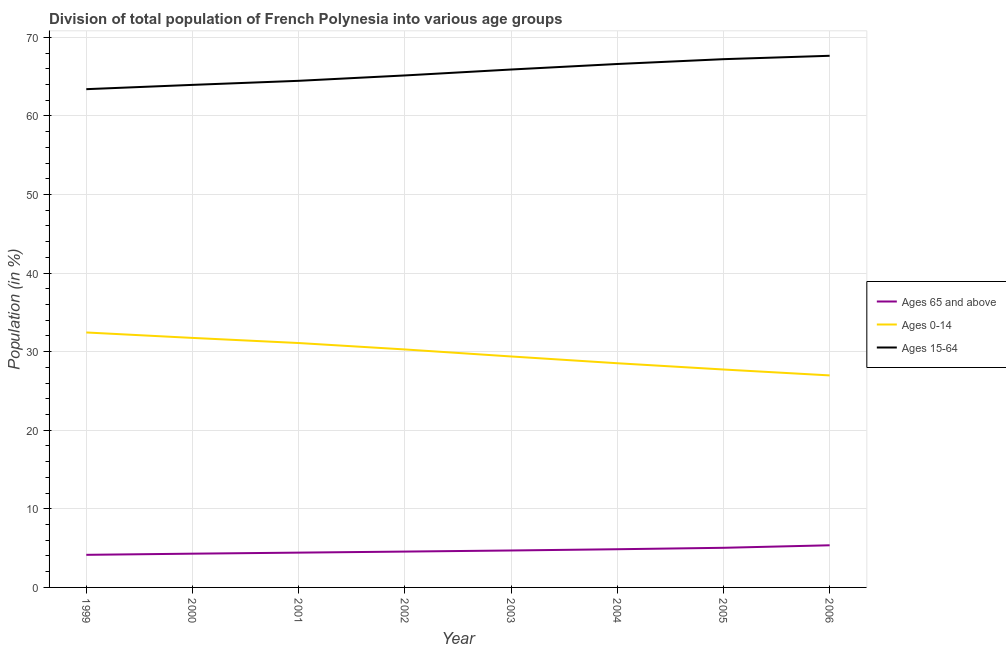Does the line corresponding to percentage of population within the age-group of 65 and above intersect with the line corresponding to percentage of population within the age-group 0-14?
Keep it short and to the point. No. Is the number of lines equal to the number of legend labels?
Give a very brief answer. Yes. What is the percentage of population within the age-group 0-14 in 2006?
Keep it short and to the point. 26.98. Across all years, what is the maximum percentage of population within the age-group 0-14?
Provide a succinct answer. 32.45. Across all years, what is the minimum percentage of population within the age-group 15-64?
Give a very brief answer. 63.41. In which year was the percentage of population within the age-group 15-64 maximum?
Keep it short and to the point. 2006. In which year was the percentage of population within the age-group 15-64 minimum?
Offer a very short reply. 1999. What is the total percentage of population within the age-group 0-14 in the graph?
Your response must be concise. 238.22. What is the difference between the percentage of population within the age-group 15-64 in 2000 and that in 2003?
Offer a very short reply. -1.95. What is the difference between the percentage of population within the age-group 15-64 in 2005 and the percentage of population within the age-group 0-14 in 2001?
Your answer should be compact. 36.12. What is the average percentage of population within the age-group 15-64 per year?
Give a very brief answer. 65.55. In the year 2003, what is the difference between the percentage of population within the age-group of 65 and above and percentage of population within the age-group 0-14?
Keep it short and to the point. -24.69. What is the ratio of the percentage of population within the age-group 15-64 in 1999 to that in 2002?
Provide a short and direct response. 0.97. What is the difference between the highest and the second highest percentage of population within the age-group 0-14?
Your answer should be compact. 0.69. What is the difference between the highest and the lowest percentage of population within the age-group 0-14?
Provide a succinct answer. 5.46. In how many years, is the percentage of population within the age-group 15-64 greater than the average percentage of population within the age-group 15-64 taken over all years?
Make the answer very short. 4. Is the sum of the percentage of population within the age-group 0-14 in 2001 and 2002 greater than the maximum percentage of population within the age-group of 65 and above across all years?
Offer a very short reply. Yes. Is it the case that in every year, the sum of the percentage of population within the age-group of 65 and above and percentage of population within the age-group 0-14 is greater than the percentage of population within the age-group 15-64?
Provide a short and direct response. No. Does the percentage of population within the age-group of 65 and above monotonically increase over the years?
Provide a short and direct response. Yes. Is the percentage of population within the age-group 15-64 strictly greater than the percentage of population within the age-group of 65 and above over the years?
Give a very brief answer. Yes. Is the percentage of population within the age-group of 65 and above strictly less than the percentage of population within the age-group 0-14 over the years?
Your response must be concise. Yes. What is the difference between two consecutive major ticks on the Y-axis?
Your answer should be compact. 10. Does the graph contain grids?
Your response must be concise. Yes. How many legend labels are there?
Your answer should be very brief. 3. What is the title of the graph?
Ensure brevity in your answer.  Division of total population of French Polynesia into various age groups
. What is the label or title of the X-axis?
Your answer should be compact. Year. What is the label or title of the Y-axis?
Provide a short and direct response. Population (in %). What is the Population (in %) in Ages 65 and above in 1999?
Give a very brief answer. 4.15. What is the Population (in %) in Ages 0-14 in 1999?
Keep it short and to the point. 32.45. What is the Population (in %) of Ages 15-64 in 1999?
Offer a very short reply. 63.41. What is the Population (in %) in Ages 65 and above in 2000?
Provide a short and direct response. 4.29. What is the Population (in %) of Ages 0-14 in 2000?
Provide a succinct answer. 31.75. What is the Population (in %) of Ages 15-64 in 2000?
Provide a short and direct response. 63.95. What is the Population (in %) in Ages 65 and above in 2001?
Provide a short and direct response. 4.43. What is the Population (in %) of Ages 0-14 in 2001?
Provide a succinct answer. 31.1. What is the Population (in %) in Ages 15-64 in 2001?
Offer a terse response. 64.47. What is the Population (in %) of Ages 65 and above in 2002?
Provide a succinct answer. 4.56. What is the Population (in %) in Ages 0-14 in 2002?
Provide a succinct answer. 30.29. What is the Population (in %) of Ages 15-64 in 2002?
Provide a succinct answer. 65.15. What is the Population (in %) of Ages 65 and above in 2003?
Your answer should be compact. 4.7. What is the Population (in %) of Ages 0-14 in 2003?
Offer a terse response. 29.39. What is the Population (in %) of Ages 15-64 in 2003?
Give a very brief answer. 65.91. What is the Population (in %) of Ages 65 and above in 2004?
Make the answer very short. 4.86. What is the Population (in %) of Ages 0-14 in 2004?
Make the answer very short. 28.53. What is the Population (in %) in Ages 15-64 in 2004?
Make the answer very short. 66.61. What is the Population (in %) of Ages 65 and above in 2005?
Offer a terse response. 5.04. What is the Population (in %) in Ages 0-14 in 2005?
Keep it short and to the point. 27.73. What is the Population (in %) of Ages 15-64 in 2005?
Keep it short and to the point. 67.22. What is the Population (in %) in Ages 65 and above in 2006?
Keep it short and to the point. 5.36. What is the Population (in %) of Ages 0-14 in 2006?
Provide a short and direct response. 26.98. What is the Population (in %) of Ages 15-64 in 2006?
Your answer should be very brief. 67.66. Across all years, what is the maximum Population (in %) in Ages 65 and above?
Your answer should be very brief. 5.36. Across all years, what is the maximum Population (in %) of Ages 0-14?
Provide a succinct answer. 32.45. Across all years, what is the maximum Population (in %) of Ages 15-64?
Your answer should be compact. 67.66. Across all years, what is the minimum Population (in %) of Ages 65 and above?
Make the answer very short. 4.15. Across all years, what is the minimum Population (in %) of Ages 0-14?
Your answer should be compact. 26.98. Across all years, what is the minimum Population (in %) in Ages 15-64?
Make the answer very short. 63.41. What is the total Population (in %) in Ages 65 and above in the graph?
Ensure brevity in your answer.  37.4. What is the total Population (in %) of Ages 0-14 in the graph?
Your answer should be compact. 238.22. What is the total Population (in %) of Ages 15-64 in the graph?
Your response must be concise. 524.38. What is the difference between the Population (in %) of Ages 65 and above in 1999 and that in 2000?
Keep it short and to the point. -0.15. What is the difference between the Population (in %) of Ages 0-14 in 1999 and that in 2000?
Offer a very short reply. 0.69. What is the difference between the Population (in %) in Ages 15-64 in 1999 and that in 2000?
Give a very brief answer. -0.55. What is the difference between the Population (in %) of Ages 65 and above in 1999 and that in 2001?
Your answer should be compact. -0.28. What is the difference between the Population (in %) in Ages 0-14 in 1999 and that in 2001?
Your response must be concise. 1.35. What is the difference between the Population (in %) of Ages 15-64 in 1999 and that in 2001?
Make the answer very short. -1.06. What is the difference between the Population (in %) in Ages 65 and above in 1999 and that in 2002?
Provide a short and direct response. -0.41. What is the difference between the Population (in %) in Ages 0-14 in 1999 and that in 2002?
Provide a succinct answer. 2.16. What is the difference between the Population (in %) of Ages 15-64 in 1999 and that in 2002?
Your answer should be very brief. -1.75. What is the difference between the Population (in %) in Ages 65 and above in 1999 and that in 2003?
Make the answer very short. -0.55. What is the difference between the Population (in %) in Ages 0-14 in 1999 and that in 2003?
Your answer should be compact. 3.05. What is the difference between the Population (in %) of Ages 15-64 in 1999 and that in 2003?
Your response must be concise. -2.5. What is the difference between the Population (in %) in Ages 65 and above in 1999 and that in 2004?
Your answer should be compact. -0.71. What is the difference between the Population (in %) of Ages 0-14 in 1999 and that in 2004?
Provide a short and direct response. 3.92. What is the difference between the Population (in %) of Ages 15-64 in 1999 and that in 2004?
Your answer should be compact. -3.2. What is the difference between the Population (in %) of Ages 65 and above in 1999 and that in 2005?
Provide a short and direct response. -0.89. What is the difference between the Population (in %) of Ages 0-14 in 1999 and that in 2005?
Provide a succinct answer. 4.71. What is the difference between the Population (in %) of Ages 15-64 in 1999 and that in 2005?
Your answer should be compact. -3.82. What is the difference between the Population (in %) in Ages 65 and above in 1999 and that in 2006?
Your answer should be very brief. -1.22. What is the difference between the Population (in %) of Ages 0-14 in 1999 and that in 2006?
Your answer should be very brief. 5.46. What is the difference between the Population (in %) of Ages 15-64 in 1999 and that in 2006?
Offer a terse response. -4.25. What is the difference between the Population (in %) of Ages 65 and above in 2000 and that in 2001?
Give a very brief answer. -0.13. What is the difference between the Population (in %) of Ages 0-14 in 2000 and that in 2001?
Your answer should be compact. 0.65. What is the difference between the Population (in %) of Ages 15-64 in 2000 and that in 2001?
Offer a very short reply. -0.52. What is the difference between the Population (in %) of Ages 65 and above in 2000 and that in 2002?
Your response must be concise. -0.27. What is the difference between the Population (in %) of Ages 0-14 in 2000 and that in 2002?
Provide a short and direct response. 1.47. What is the difference between the Population (in %) of Ages 15-64 in 2000 and that in 2002?
Ensure brevity in your answer.  -1.2. What is the difference between the Population (in %) in Ages 65 and above in 2000 and that in 2003?
Make the answer very short. -0.41. What is the difference between the Population (in %) in Ages 0-14 in 2000 and that in 2003?
Provide a short and direct response. 2.36. What is the difference between the Population (in %) of Ages 15-64 in 2000 and that in 2003?
Keep it short and to the point. -1.95. What is the difference between the Population (in %) of Ages 65 and above in 2000 and that in 2004?
Ensure brevity in your answer.  -0.57. What is the difference between the Population (in %) in Ages 0-14 in 2000 and that in 2004?
Keep it short and to the point. 3.22. What is the difference between the Population (in %) of Ages 15-64 in 2000 and that in 2004?
Make the answer very short. -2.66. What is the difference between the Population (in %) of Ages 65 and above in 2000 and that in 2005?
Your answer should be very brief. -0.75. What is the difference between the Population (in %) in Ages 0-14 in 2000 and that in 2005?
Your answer should be very brief. 4.02. What is the difference between the Population (in %) in Ages 15-64 in 2000 and that in 2005?
Make the answer very short. -3.27. What is the difference between the Population (in %) in Ages 65 and above in 2000 and that in 2006?
Keep it short and to the point. -1.07. What is the difference between the Population (in %) of Ages 0-14 in 2000 and that in 2006?
Ensure brevity in your answer.  4.77. What is the difference between the Population (in %) of Ages 15-64 in 2000 and that in 2006?
Keep it short and to the point. -3.7. What is the difference between the Population (in %) of Ages 65 and above in 2001 and that in 2002?
Your answer should be compact. -0.13. What is the difference between the Population (in %) in Ages 0-14 in 2001 and that in 2002?
Offer a very short reply. 0.82. What is the difference between the Population (in %) in Ages 15-64 in 2001 and that in 2002?
Give a very brief answer. -0.68. What is the difference between the Population (in %) in Ages 65 and above in 2001 and that in 2003?
Keep it short and to the point. -0.27. What is the difference between the Population (in %) of Ages 0-14 in 2001 and that in 2003?
Ensure brevity in your answer.  1.71. What is the difference between the Population (in %) in Ages 15-64 in 2001 and that in 2003?
Provide a succinct answer. -1.44. What is the difference between the Population (in %) of Ages 65 and above in 2001 and that in 2004?
Make the answer very short. -0.43. What is the difference between the Population (in %) of Ages 0-14 in 2001 and that in 2004?
Provide a short and direct response. 2.57. What is the difference between the Population (in %) in Ages 15-64 in 2001 and that in 2004?
Ensure brevity in your answer.  -2.14. What is the difference between the Population (in %) of Ages 65 and above in 2001 and that in 2005?
Your response must be concise. -0.61. What is the difference between the Population (in %) of Ages 0-14 in 2001 and that in 2005?
Ensure brevity in your answer.  3.37. What is the difference between the Population (in %) in Ages 15-64 in 2001 and that in 2005?
Provide a short and direct response. -2.75. What is the difference between the Population (in %) in Ages 65 and above in 2001 and that in 2006?
Offer a very short reply. -0.93. What is the difference between the Population (in %) in Ages 0-14 in 2001 and that in 2006?
Your answer should be very brief. 4.12. What is the difference between the Population (in %) in Ages 15-64 in 2001 and that in 2006?
Give a very brief answer. -3.19. What is the difference between the Population (in %) of Ages 65 and above in 2002 and that in 2003?
Make the answer very short. -0.14. What is the difference between the Population (in %) in Ages 0-14 in 2002 and that in 2003?
Keep it short and to the point. 0.89. What is the difference between the Population (in %) in Ages 15-64 in 2002 and that in 2003?
Make the answer very short. -0.75. What is the difference between the Population (in %) in Ages 65 and above in 2002 and that in 2004?
Make the answer very short. -0.3. What is the difference between the Population (in %) in Ages 0-14 in 2002 and that in 2004?
Make the answer very short. 1.75. What is the difference between the Population (in %) of Ages 15-64 in 2002 and that in 2004?
Offer a very short reply. -1.46. What is the difference between the Population (in %) of Ages 65 and above in 2002 and that in 2005?
Make the answer very short. -0.48. What is the difference between the Population (in %) in Ages 0-14 in 2002 and that in 2005?
Your response must be concise. 2.55. What is the difference between the Population (in %) of Ages 15-64 in 2002 and that in 2005?
Keep it short and to the point. -2.07. What is the difference between the Population (in %) of Ages 65 and above in 2002 and that in 2006?
Ensure brevity in your answer.  -0.8. What is the difference between the Population (in %) of Ages 0-14 in 2002 and that in 2006?
Make the answer very short. 3.3. What is the difference between the Population (in %) of Ages 15-64 in 2002 and that in 2006?
Your answer should be compact. -2.5. What is the difference between the Population (in %) of Ages 65 and above in 2003 and that in 2004?
Keep it short and to the point. -0.16. What is the difference between the Population (in %) in Ages 0-14 in 2003 and that in 2004?
Keep it short and to the point. 0.86. What is the difference between the Population (in %) in Ages 15-64 in 2003 and that in 2004?
Ensure brevity in your answer.  -0.7. What is the difference between the Population (in %) in Ages 65 and above in 2003 and that in 2005?
Ensure brevity in your answer.  -0.34. What is the difference between the Population (in %) of Ages 0-14 in 2003 and that in 2005?
Offer a terse response. 1.66. What is the difference between the Population (in %) in Ages 15-64 in 2003 and that in 2005?
Your answer should be compact. -1.32. What is the difference between the Population (in %) in Ages 65 and above in 2003 and that in 2006?
Offer a very short reply. -0.66. What is the difference between the Population (in %) in Ages 0-14 in 2003 and that in 2006?
Your response must be concise. 2.41. What is the difference between the Population (in %) in Ages 15-64 in 2003 and that in 2006?
Provide a succinct answer. -1.75. What is the difference between the Population (in %) of Ages 65 and above in 2004 and that in 2005?
Make the answer very short. -0.18. What is the difference between the Population (in %) in Ages 0-14 in 2004 and that in 2005?
Provide a short and direct response. 0.8. What is the difference between the Population (in %) in Ages 15-64 in 2004 and that in 2005?
Provide a succinct answer. -0.62. What is the difference between the Population (in %) of Ages 65 and above in 2004 and that in 2006?
Offer a terse response. -0.5. What is the difference between the Population (in %) in Ages 0-14 in 2004 and that in 2006?
Keep it short and to the point. 1.55. What is the difference between the Population (in %) in Ages 15-64 in 2004 and that in 2006?
Provide a succinct answer. -1.05. What is the difference between the Population (in %) in Ages 65 and above in 2005 and that in 2006?
Give a very brief answer. -0.32. What is the difference between the Population (in %) of Ages 0-14 in 2005 and that in 2006?
Your answer should be compact. 0.75. What is the difference between the Population (in %) in Ages 15-64 in 2005 and that in 2006?
Ensure brevity in your answer.  -0.43. What is the difference between the Population (in %) of Ages 65 and above in 1999 and the Population (in %) of Ages 0-14 in 2000?
Give a very brief answer. -27.6. What is the difference between the Population (in %) of Ages 65 and above in 1999 and the Population (in %) of Ages 15-64 in 2000?
Offer a terse response. -59.8. What is the difference between the Population (in %) in Ages 0-14 in 1999 and the Population (in %) in Ages 15-64 in 2000?
Keep it short and to the point. -31.51. What is the difference between the Population (in %) in Ages 65 and above in 1999 and the Population (in %) in Ages 0-14 in 2001?
Provide a short and direct response. -26.95. What is the difference between the Population (in %) of Ages 65 and above in 1999 and the Population (in %) of Ages 15-64 in 2001?
Keep it short and to the point. -60.32. What is the difference between the Population (in %) in Ages 0-14 in 1999 and the Population (in %) in Ages 15-64 in 2001?
Make the answer very short. -32.03. What is the difference between the Population (in %) of Ages 65 and above in 1999 and the Population (in %) of Ages 0-14 in 2002?
Offer a terse response. -26.14. What is the difference between the Population (in %) of Ages 65 and above in 1999 and the Population (in %) of Ages 15-64 in 2002?
Provide a succinct answer. -61.01. What is the difference between the Population (in %) in Ages 0-14 in 1999 and the Population (in %) in Ages 15-64 in 2002?
Offer a very short reply. -32.71. What is the difference between the Population (in %) in Ages 65 and above in 1999 and the Population (in %) in Ages 0-14 in 2003?
Offer a very short reply. -25.24. What is the difference between the Population (in %) in Ages 65 and above in 1999 and the Population (in %) in Ages 15-64 in 2003?
Your answer should be very brief. -61.76. What is the difference between the Population (in %) in Ages 0-14 in 1999 and the Population (in %) in Ages 15-64 in 2003?
Provide a short and direct response. -33.46. What is the difference between the Population (in %) in Ages 65 and above in 1999 and the Population (in %) in Ages 0-14 in 2004?
Ensure brevity in your answer.  -24.38. What is the difference between the Population (in %) of Ages 65 and above in 1999 and the Population (in %) of Ages 15-64 in 2004?
Offer a very short reply. -62.46. What is the difference between the Population (in %) in Ages 0-14 in 1999 and the Population (in %) in Ages 15-64 in 2004?
Your answer should be very brief. -34.16. What is the difference between the Population (in %) of Ages 65 and above in 1999 and the Population (in %) of Ages 0-14 in 2005?
Ensure brevity in your answer.  -23.59. What is the difference between the Population (in %) in Ages 65 and above in 1999 and the Population (in %) in Ages 15-64 in 2005?
Provide a succinct answer. -63.08. What is the difference between the Population (in %) in Ages 0-14 in 1999 and the Population (in %) in Ages 15-64 in 2005?
Provide a succinct answer. -34.78. What is the difference between the Population (in %) of Ages 65 and above in 1999 and the Population (in %) of Ages 0-14 in 2006?
Offer a very short reply. -22.83. What is the difference between the Population (in %) in Ages 65 and above in 1999 and the Population (in %) in Ages 15-64 in 2006?
Ensure brevity in your answer.  -63.51. What is the difference between the Population (in %) in Ages 0-14 in 1999 and the Population (in %) in Ages 15-64 in 2006?
Offer a terse response. -35.21. What is the difference between the Population (in %) of Ages 65 and above in 2000 and the Population (in %) of Ages 0-14 in 2001?
Ensure brevity in your answer.  -26.81. What is the difference between the Population (in %) in Ages 65 and above in 2000 and the Population (in %) in Ages 15-64 in 2001?
Your answer should be very brief. -60.18. What is the difference between the Population (in %) of Ages 0-14 in 2000 and the Population (in %) of Ages 15-64 in 2001?
Your response must be concise. -32.72. What is the difference between the Population (in %) of Ages 65 and above in 2000 and the Population (in %) of Ages 0-14 in 2002?
Make the answer very short. -25.99. What is the difference between the Population (in %) of Ages 65 and above in 2000 and the Population (in %) of Ages 15-64 in 2002?
Provide a short and direct response. -60.86. What is the difference between the Population (in %) of Ages 0-14 in 2000 and the Population (in %) of Ages 15-64 in 2002?
Make the answer very short. -33.4. What is the difference between the Population (in %) in Ages 65 and above in 2000 and the Population (in %) in Ages 0-14 in 2003?
Provide a succinct answer. -25.1. What is the difference between the Population (in %) in Ages 65 and above in 2000 and the Population (in %) in Ages 15-64 in 2003?
Provide a short and direct response. -61.61. What is the difference between the Population (in %) in Ages 0-14 in 2000 and the Population (in %) in Ages 15-64 in 2003?
Your answer should be very brief. -34.15. What is the difference between the Population (in %) of Ages 65 and above in 2000 and the Population (in %) of Ages 0-14 in 2004?
Your response must be concise. -24.24. What is the difference between the Population (in %) in Ages 65 and above in 2000 and the Population (in %) in Ages 15-64 in 2004?
Your response must be concise. -62.31. What is the difference between the Population (in %) of Ages 0-14 in 2000 and the Population (in %) of Ages 15-64 in 2004?
Your answer should be very brief. -34.86. What is the difference between the Population (in %) in Ages 65 and above in 2000 and the Population (in %) in Ages 0-14 in 2005?
Offer a very short reply. -23.44. What is the difference between the Population (in %) in Ages 65 and above in 2000 and the Population (in %) in Ages 15-64 in 2005?
Ensure brevity in your answer.  -62.93. What is the difference between the Population (in %) of Ages 0-14 in 2000 and the Population (in %) of Ages 15-64 in 2005?
Offer a terse response. -35.47. What is the difference between the Population (in %) in Ages 65 and above in 2000 and the Population (in %) in Ages 0-14 in 2006?
Your answer should be compact. -22.69. What is the difference between the Population (in %) in Ages 65 and above in 2000 and the Population (in %) in Ages 15-64 in 2006?
Offer a very short reply. -63.36. What is the difference between the Population (in %) of Ages 0-14 in 2000 and the Population (in %) of Ages 15-64 in 2006?
Give a very brief answer. -35.9. What is the difference between the Population (in %) in Ages 65 and above in 2001 and the Population (in %) in Ages 0-14 in 2002?
Provide a succinct answer. -25.86. What is the difference between the Population (in %) in Ages 65 and above in 2001 and the Population (in %) in Ages 15-64 in 2002?
Provide a succinct answer. -60.73. What is the difference between the Population (in %) of Ages 0-14 in 2001 and the Population (in %) of Ages 15-64 in 2002?
Keep it short and to the point. -34.05. What is the difference between the Population (in %) in Ages 65 and above in 2001 and the Population (in %) in Ages 0-14 in 2003?
Your answer should be compact. -24.96. What is the difference between the Population (in %) of Ages 65 and above in 2001 and the Population (in %) of Ages 15-64 in 2003?
Give a very brief answer. -61.48. What is the difference between the Population (in %) of Ages 0-14 in 2001 and the Population (in %) of Ages 15-64 in 2003?
Offer a terse response. -34.81. What is the difference between the Population (in %) of Ages 65 and above in 2001 and the Population (in %) of Ages 0-14 in 2004?
Ensure brevity in your answer.  -24.1. What is the difference between the Population (in %) in Ages 65 and above in 2001 and the Population (in %) in Ages 15-64 in 2004?
Ensure brevity in your answer.  -62.18. What is the difference between the Population (in %) in Ages 0-14 in 2001 and the Population (in %) in Ages 15-64 in 2004?
Your answer should be compact. -35.51. What is the difference between the Population (in %) of Ages 65 and above in 2001 and the Population (in %) of Ages 0-14 in 2005?
Provide a short and direct response. -23.3. What is the difference between the Population (in %) of Ages 65 and above in 2001 and the Population (in %) of Ages 15-64 in 2005?
Your response must be concise. -62.8. What is the difference between the Population (in %) in Ages 0-14 in 2001 and the Population (in %) in Ages 15-64 in 2005?
Your answer should be very brief. -36.12. What is the difference between the Population (in %) of Ages 65 and above in 2001 and the Population (in %) of Ages 0-14 in 2006?
Make the answer very short. -22.55. What is the difference between the Population (in %) of Ages 65 and above in 2001 and the Population (in %) of Ages 15-64 in 2006?
Provide a succinct answer. -63.23. What is the difference between the Population (in %) in Ages 0-14 in 2001 and the Population (in %) in Ages 15-64 in 2006?
Provide a short and direct response. -36.56. What is the difference between the Population (in %) of Ages 65 and above in 2002 and the Population (in %) of Ages 0-14 in 2003?
Your response must be concise. -24.83. What is the difference between the Population (in %) of Ages 65 and above in 2002 and the Population (in %) of Ages 15-64 in 2003?
Your response must be concise. -61.35. What is the difference between the Population (in %) of Ages 0-14 in 2002 and the Population (in %) of Ages 15-64 in 2003?
Make the answer very short. -35.62. What is the difference between the Population (in %) of Ages 65 and above in 2002 and the Population (in %) of Ages 0-14 in 2004?
Provide a succinct answer. -23.97. What is the difference between the Population (in %) in Ages 65 and above in 2002 and the Population (in %) in Ages 15-64 in 2004?
Your answer should be very brief. -62.05. What is the difference between the Population (in %) in Ages 0-14 in 2002 and the Population (in %) in Ages 15-64 in 2004?
Give a very brief answer. -36.32. What is the difference between the Population (in %) in Ages 65 and above in 2002 and the Population (in %) in Ages 0-14 in 2005?
Ensure brevity in your answer.  -23.17. What is the difference between the Population (in %) of Ages 65 and above in 2002 and the Population (in %) of Ages 15-64 in 2005?
Keep it short and to the point. -62.66. What is the difference between the Population (in %) in Ages 0-14 in 2002 and the Population (in %) in Ages 15-64 in 2005?
Give a very brief answer. -36.94. What is the difference between the Population (in %) of Ages 65 and above in 2002 and the Population (in %) of Ages 0-14 in 2006?
Offer a terse response. -22.42. What is the difference between the Population (in %) of Ages 65 and above in 2002 and the Population (in %) of Ages 15-64 in 2006?
Your response must be concise. -63.09. What is the difference between the Population (in %) in Ages 0-14 in 2002 and the Population (in %) in Ages 15-64 in 2006?
Give a very brief answer. -37.37. What is the difference between the Population (in %) of Ages 65 and above in 2003 and the Population (in %) of Ages 0-14 in 2004?
Make the answer very short. -23.83. What is the difference between the Population (in %) of Ages 65 and above in 2003 and the Population (in %) of Ages 15-64 in 2004?
Your answer should be compact. -61.91. What is the difference between the Population (in %) in Ages 0-14 in 2003 and the Population (in %) in Ages 15-64 in 2004?
Keep it short and to the point. -37.22. What is the difference between the Population (in %) of Ages 65 and above in 2003 and the Population (in %) of Ages 0-14 in 2005?
Give a very brief answer. -23.03. What is the difference between the Population (in %) in Ages 65 and above in 2003 and the Population (in %) in Ages 15-64 in 2005?
Make the answer very short. -62.52. What is the difference between the Population (in %) in Ages 0-14 in 2003 and the Population (in %) in Ages 15-64 in 2005?
Offer a terse response. -37.83. What is the difference between the Population (in %) of Ages 65 and above in 2003 and the Population (in %) of Ages 0-14 in 2006?
Give a very brief answer. -22.28. What is the difference between the Population (in %) in Ages 65 and above in 2003 and the Population (in %) in Ages 15-64 in 2006?
Give a very brief answer. -62.96. What is the difference between the Population (in %) in Ages 0-14 in 2003 and the Population (in %) in Ages 15-64 in 2006?
Make the answer very short. -38.26. What is the difference between the Population (in %) in Ages 65 and above in 2004 and the Population (in %) in Ages 0-14 in 2005?
Your response must be concise. -22.87. What is the difference between the Population (in %) of Ages 65 and above in 2004 and the Population (in %) of Ages 15-64 in 2005?
Offer a terse response. -62.36. What is the difference between the Population (in %) of Ages 0-14 in 2004 and the Population (in %) of Ages 15-64 in 2005?
Keep it short and to the point. -38.69. What is the difference between the Population (in %) in Ages 65 and above in 2004 and the Population (in %) in Ages 0-14 in 2006?
Offer a very short reply. -22.12. What is the difference between the Population (in %) in Ages 65 and above in 2004 and the Population (in %) in Ages 15-64 in 2006?
Provide a short and direct response. -62.8. What is the difference between the Population (in %) in Ages 0-14 in 2004 and the Population (in %) in Ages 15-64 in 2006?
Offer a very short reply. -39.13. What is the difference between the Population (in %) of Ages 65 and above in 2005 and the Population (in %) of Ages 0-14 in 2006?
Your answer should be very brief. -21.94. What is the difference between the Population (in %) in Ages 65 and above in 2005 and the Population (in %) in Ages 15-64 in 2006?
Your response must be concise. -62.61. What is the difference between the Population (in %) in Ages 0-14 in 2005 and the Population (in %) in Ages 15-64 in 2006?
Offer a terse response. -39.92. What is the average Population (in %) in Ages 65 and above per year?
Your response must be concise. 4.67. What is the average Population (in %) of Ages 0-14 per year?
Keep it short and to the point. 29.78. What is the average Population (in %) of Ages 15-64 per year?
Provide a succinct answer. 65.55. In the year 1999, what is the difference between the Population (in %) in Ages 65 and above and Population (in %) in Ages 0-14?
Keep it short and to the point. -28.3. In the year 1999, what is the difference between the Population (in %) in Ages 65 and above and Population (in %) in Ages 15-64?
Ensure brevity in your answer.  -59.26. In the year 1999, what is the difference between the Population (in %) of Ages 0-14 and Population (in %) of Ages 15-64?
Make the answer very short. -30.96. In the year 2000, what is the difference between the Population (in %) of Ages 65 and above and Population (in %) of Ages 0-14?
Give a very brief answer. -27.46. In the year 2000, what is the difference between the Population (in %) in Ages 65 and above and Population (in %) in Ages 15-64?
Make the answer very short. -59.66. In the year 2000, what is the difference between the Population (in %) of Ages 0-14 and Population (in %) of Ages 15-64?
Your answer should be very brief. -32.2. In the year 2001, what is the difference between the Population (in %) in Ages 65 and above and Population (in %) in Ages 0-14?
Keep it short and to the point. -26.67. In the year 2001, what is the difference between the Population (in %) of Ages 65 and above and Population (in %) of Ages 15-64?
Offer a very short reply. -60.04. In the year 2001, what is the difference between the Population (in %) of Ages 0-14 and Population (in %) of Ages 15-64?
Provide a succinct answer. -33.37. In the year 2002, what is the difference between the Population (in %) in Ages 65 and above and Population (in %) in Ages 0-14?
Provide a short and direct response. -25.72. In the year 2002, what is the difference between the Population (in %) in Ages 65 and above and Population (in %) in Ages 15-64?
Offer a terse response. -60.59. In the year 2002, what is the difference between the Population (in %) of Ages 0-14 and Population (in %) of Ages 15-64?
Provide a succinct answer. -34.87. In the year 2003, what is the difference between the Population (in %) in Ages 65 and above and Population (in %) in Ages 0-14?
Keep it short and to the point. -24.69. In the year 2003, what is the difference between the Population (in %) in Ages 65 and above and Population (in %) in Ages 15-64?
Provide a short and direct response. -61.21. In the year 2003, what is the difference between the Population (in %) in Ages 0-14 and Population (in %) in Ages 15-64?
Keep it short and to the point. -36.52. In the year 2004, what is the difference between the Population (in %) of Ages 65 and above and Population (in %) of Ages 0-14?
Provide a succinct answer. -23.67. In the year 2004, what is the difference between the Population (in %) in Ages 65 and above and Population (in %) in Ages 15-64?
Ensure brevity in your answer.  -61.75. In the year 2004, what is the difference between the Population (in %) in Ages 0-14 and Population (in %) in Ages 15-64?
Your response must be concise. -38.08. In the year 2005, what is the difference between the Population (in %) of Ages 65 and above and Population (in %) of Ages 0-14?
Provide a short and direct response. -22.69. In the year 2005, what is the difference between the Population (in %) in Ages 65 and above and Population (in %) in Ages 15-64?
Provide a short and direct response. -62.18. In the year 2005, what is the difference between the Population (in %) in Ages 0-14 and Population (in %) in Ages 15-64?
Your answer should be compact. -39.49. In the year 2006, what is the difference between the Population (in %) of Ages 65 and above and Population (in %) of Ages 0-14?
Provide a succinct answer. -21.62. In the year 2006, what is the difference between the Population (in %) in Ages 65 and above and Population (in %) in Ages 15-64?
Ensure brevity in your answer.  -62.29. In the year 2006, what is the difference between the Population (in %) of Ages 0-14 and Population (in %) of Ages 15-64?
Provide a short and direct response. -40.68. What is the ratio of the Population (in %) of Ages 65 and above in 1999 to that in 2000?
Ensure brevity in your answer.  0.97. What is the ratio of the Population (in %) of Ages 0-14 in 1999 to that in 2000?
Your response must be concise. 1.02. What is the ratio of the Population (in %) of Ages 15-64 in 1999 to that in 2000?
Your answer should be compact. 0.99. What is the ratio of the Population (in %) of Ages 65 and above in 1999 to that in 2001?
Offer a terse response. 0.94. What is the ratio of the Population (in %) of Ages 0-14 in 1999 to that in 2001?
Give a very brief answer. 1.04. What is the ratio of the Population (in %) in Ages 15-64 in 1999 to that in 2001?
Offer a terse response. 0.98. What is the ratio of the Population (in %) in Ages 65 and above in 1999 to that in 2002?
Give a very brief answer. 0.91. What is the ratio of the Population (in %) of Ages 0-14 in 1999 to that in 2002?
Keep it short and to the point. 1.07. What is the ratio of the Population (in %) in Ages 15-64 in 1999 to that in 2002?
Make the answer very short. 0.97. What is the ratio of the Population (in %) in Ages 65 and above in 1999 to that in 2003?
Make the answer very short. 0.88. What is the ratio of the Population (in %) in Ages 0-14 in 1999 to that in 2003?
Provide a short and direct response. 1.1. What is the ratio of the Population (in %) of Ages 15-64 in 1999 to that in 2003?
Your answer should be very brief. 0.96. What is the ratio of the Population (in %) in Ages 65 and above in 1999 to that in 2004?
Give a very brief answer. 0.85. What is the ratio of the Population (in %) of Ages 0-14 in 1999 to that in 2004?
Provide a succinct answer. 1.14. What is the ratio of the Population (in %) in Ages 15-64 in 1999 to that in 2004?
Provide a succinct answer. 0.95. What is the ratio of the Population (in %) in Ages 65 and above in 1999 to that in 2005?
Provide a short and direct response. 0.82. What is the ratio of the Population (in %) in Ages 0-14 in 1999 to that in 2005?
Offer a terse response. 1.17. What is the ratio of the Population (in %) in Ages 15-64 in 1999 to that in 2005?
Your answer should be very brief. 0.94. What is the ratio of the Population (in %) of Ages 65 and above in 1999 to that in 2006?
Offer a very short reply. 0.77. What is the ratio of the Population (in %) in Ages 0-14 in 1999 to that in 2006?
Make the answer very short. 1.2. What is the ratio of the Population (in %) of Ages 15-64 in 1999 to that in 2006?
Give a very brief answer. 0.94. What is the ratio of the Population (in %) of Ages 65 and above in 2000 to that in 2001?
Give a very brief answer. 0.97. What is the ratio of the Population (in %) in Ages 0-14 in 2000 to that in 2001?
Provide a short and direct response. 1.02. What is the ratio of the Population (in %) of Ages 15-64 in 2000 to that in 2001?
Ensure brevity in your answer.  0.99. What is the ratio of the Population (in %) of Ages 65 and above in 2000 to that in 2002?
Give a very brief answer. 0.94. What is the ratio of the Population (in %) of Ages 0-14 in 2000 to that in 2002?
Provide a short and direct response. 1.05. What is the ratio of the Population (in %) in Ages 15-64 in 2000 to that in 2002?
Keep it short and to the point. 0.98. What is the ratio of the Population (in %) in Ages 65 and above in 2000 to that in 2003?
Give a very brief answer. 0.91. What is the ratio of the Population (in %) of Ages 0-14 in 2000 to that in 2003?
Keep it short and to the point. 1.08. What is the ratio of the Population (in %) in Ages 15-64 in 2000 to that in 2003?
Your answer should be very brief. 0.97. What is the ratio of the Population (in %) of Ages 65 and above in 2000 to that in 2004?
Give a very brief answer. 0.88. What is the ratio of the Population (in %) in Ages 0-14 in 2000 to that in 2004?
Make the answer very short. 1.11. What is the ratio of the Population (in %) of Ages 15-64 in 2000 to that in 2004?
Give a very brief answer. 0.96. What is the ratio of the Population (in %) in Ages 65 and above in 2000 to that in 2005?
Your answer should be compact. 0.85. What is the ratio of the Population (in %) in Ages 0-14 in 2000 to that in 2005?
Your response must be concise. 1.14. What is the ratio of the Population (in %) of Ages 15-64 in 2000 to that in 2005?
Offer a terse response. 0.95. What is the ratio of the Population (in %) in Ages 65 and above in 2000 to that in 2006?
Give a very brief answer. 0.8. What is the ratio of the Population (in %) in Ages 0-14 in 2000 to that in 2006?
Keep it short and to the point. 1.18. What is the ratio of the Population (in %) of Ages 15-64 in 2000 to that in 2006?
Your answer should be compact. 0.95. What is the ratio of the Population (in %) in Ages 65 and above in 2001 to that in 2002?
Your answer should be compact. 0.97. What is the ratio of the Population (in %) of Ages 0-14 in 2001 to that in 2002?
Your answer should be compact. 1.03. What is the ratio of the Population (in %) in Ages 15-64 in 2001 to that in 2002?
Your answer should be very brief. 0.99. What is the ratio of the Population (in %) in Ages 65 and above in 2001 to that in 2003?
Provide a short and direct response. 0.94. What is the ratio of the Population (in %) in Ages 0-14 in 2001 to that in 2003?
Your answer should be compact. 1.06. What is the ratio of the Population (in %) of Ages 15-64 in 2001 to that in 2003?
Keep it short and to the point. 0.98. What is the ratio of the Population (in %) of Ages 65 and above in 2001 to that in 2004?
Keep it short and to the point. 0.91. What is the ratio of the Population (in %) in Ages 0-14 in 2001 to that in 2004?
Give a very brief answer. 1.09. What is the ratio of the Population (in %) in Ages 15-64 in 2001 to that in 2004?
Ensure brevity in your answer.  0.97. What is the ratio of the Population (in %) in Ages 65 and above in 2001 to that in 2005?
Your response must be concise. 0.88. What is the ratio of the Population (in %) of Ages 0-14 in 2001 to that in 2005?
Your answer should be compact. 1.12. What is the ratio of the Population (in %) in Ages 15-64 in 2001 to that in 2005?
Your answer should be very brief. 0.96. What is the ratio of the Population (in %) of Ages 65 and above in 2001 to that in 2006?
Provide a succinct answer. 0.83. What is the ratio of the Population (in %) of Ages 0-14 in 2001 to that in 2006?
Provide a succinct answer. 1.15. What is the ratio of the Population (in %) of Ages 15-64 in 2001 to that in 2006?
Offer a terse response. 0.95. What is the ratio of the Population (in %) in Ages 65 and above in 2002 to that in 2003?
Your answer should be compact. 0.97. What is the ratio of the Population (in %) in Ages 0-14 in 2002 to that in 2003?
Offer a very short reply. 1.03. What is the ratio of the Population (in %) of Ages 65 and above in 2002 to that in 2004?
Provide a short and direct response. 0.94. What is the ratio of the Population (in %) of Ages 0-14 in 2002 to that in 2004?
Keep it short and to the point. 1.06. What is the ratio of the Population (in %) of Ages 15-64 in 2002 to that in 2004?
Your answer should be compact. 0.98. What is the ratio of the Population (in %) in Ages 65 and above in 2002 to that in 2005?
Offer a very short reply. 0.9. What is the ratio of the Population (in %) of Ages 0-14 in 2002 to that in 2005?
Ensure brevity in your answer.  1.09. What is the ratio of the Population (in %) in Ages 15-64 in 2002 to that in 2005?
Offer a very short reply. 0.97. What is the ratio of the Population (in %) of Ages 65 and above in 2002 to that in 2006?
Your answer should be very brief. 0.85. What is the ratio of the Population (in %) of Ages 0-14 in 2002 to that in 2006?
Offer a very short reply. 1.12. What is the ratio of the Population (in %) in Ages 65 and above in 2003 to that in 2004?
Make the answer very short. 0.97. What is the ratio of the Population (in %) of Ages 0-14 in 2003 to that in 2004?
Your answer should be very brief. 1.03. What is the ratio of the Population (in %) of Ages 65 and above in 2003 to that in 2005?
Provide a short and direct response. 0.93. What is the ratio of the Population (in %) in Ages 0-14 in 2003 to that in 2005?
Your answer should be very brief. 1.06. What is the ratio of the Population (in %) in Ages 15-64 in 2003 to that in 2005?
Make the answer very short. 0.98. What is the ratio of the Population (in %) in Ages 65 and above in 2003 to that in 2006?
Your answer should be very brief. 0.88. What is the ratio of the Population (in %) in Ages 0-14 in 2003 to that in 2006?
Provide a succinct answer. 1.09. What is the ratio of the Population (in %) of Ages 15-64 in 2003 to that in 2006?
Make the answer very short. 0.97. What is the ratio of the Population (in %) in Ages 65 and above in 2004 to that in 2005?
Ensure brevity in your answer.  0.96. What is the ratio of the Population (in %) in Ages 0-14 in 2004 to that in 2005?
Give a very brief answer. 1.03. What is the ratio of the Population (in %) of Ages 65 and above in 2004 to that in 2006?
Offer a very short reply. 0.91. What is the ratio of the Population (in %) in Ages 0-14 in 2004 to that in 2006?
Keep it short and to the point. 1.06. What is the ratio of the Population (in %) of Ages 15-64 in 2004 to that in 2006?
Provide a short and direct response. 0.98. What is the ratio of the Population (in %) of Ages 65 and above in 2005 to that in 2006?
Your answer should be very brief. 0.94. What is the ratio of the Population (in %) of Ages 0-14 in 2005 to that in 2006?
Provide a short and direct response. 1.03. What is the difference between the highest and the second highest Population (in %) in Ages 65 and above?
Your response must be concise. 0.32. What is the difference between the highest and the second highest Population (in %) of Ages 0-14?
Your answer should be very brief. 0.69. What is the difference between the highest and the second highest Population (in %) of Ages 15-64?
Make the answer very short. 0.43. What is the difference between the highest and the lowest Population (in %) in Ages 65 and above?
Keep it short and to the point. 1.22. What is the difference between the highest and the lowest Population (in %) in Ages 0-14?
Ensure brevity in your answer.  5.46. What is the difference between the highest and the lowest Population (in %) in Ages 15-64?
Make the answer very short. 4.25. 